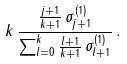Convert formula to latex. <formula><loc_0><loc_0><loc_500><loc_500>k \, \frac { \frac { j + 1 } { k + 1 } \, \sigma _ { j + 1 } ^ { ( 1 ) } } { \sum _ { l = 0 } ^ { k } \frac { l + 1 } { k + 1 } \, \sigma _ { l + 1 } ^ { ( 1 ) } } \, .</formula> 